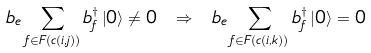Convert formula to latex. <formula><loc_0><loc_0><loc_500><loc_500>b _ { e } \sum _ { f \in F ( c ( i , j ) ) } b ^ { \dagger } _ { f } \left | 0 \right \rangle \neq 0 \ \Rightarrow \ b _ { e } \sum _ { f \in F ( c ( i , k ) ) } b ^ { \dagger } _ { f } \left | 0 \right \rangle = 0</formula> 